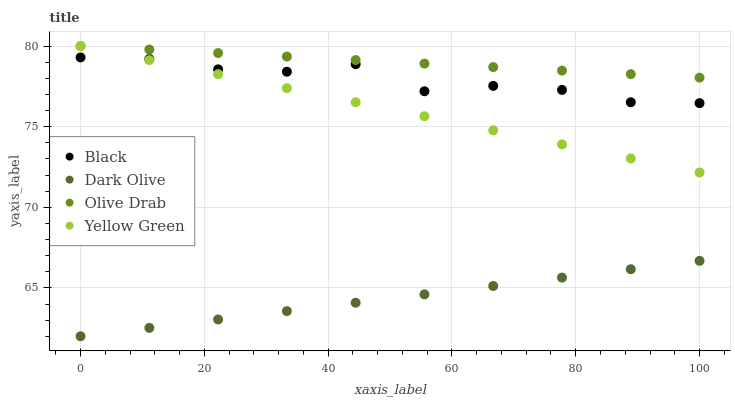Does Dark Olive have the minimum area under the curve?
Answer yes or no. Yes. Does Olive Drab have the maximum area under the curve?
Answer yes or no. Yes. Does Black have the minimum area under the curve?
Answer yes or no. No. Does Black have the maximum area under the curve?
Answer yes or no. No. Is Olive Drab the smoothest?
Answer yes or no. Yes. Is Black the roughest?
Answer yes or no. Yes. Is Yellow Green the smoothest?
Answer yes or no. No. Is Yellow Green the roughest?
Answer yes or no. No. Does Dark Olive have the lowest value?
Answer yes or no. Yes. Does Black have the lowest value?
Answer yes or no. No. Does Olive Drab have the highest value?
Answer yes or no. Yes. Does Black have the highest value?
Answer yes or no. No. Is Dark Olive less than Olive Drab?
Answer yes or no. Yes. Is Olive Drab greater than Dark Olive?
Answer yes or no. Yes. Does Black intersect Yellow Green?
Answer yes or no. Yes. Is Black less than Yellow Green?
Answer yes or no. No. Is Black greater than Yellow Green?
Answer yes or no. No. Does Dark Olive intersect Olive Drab?
Answer yes or no. No. 